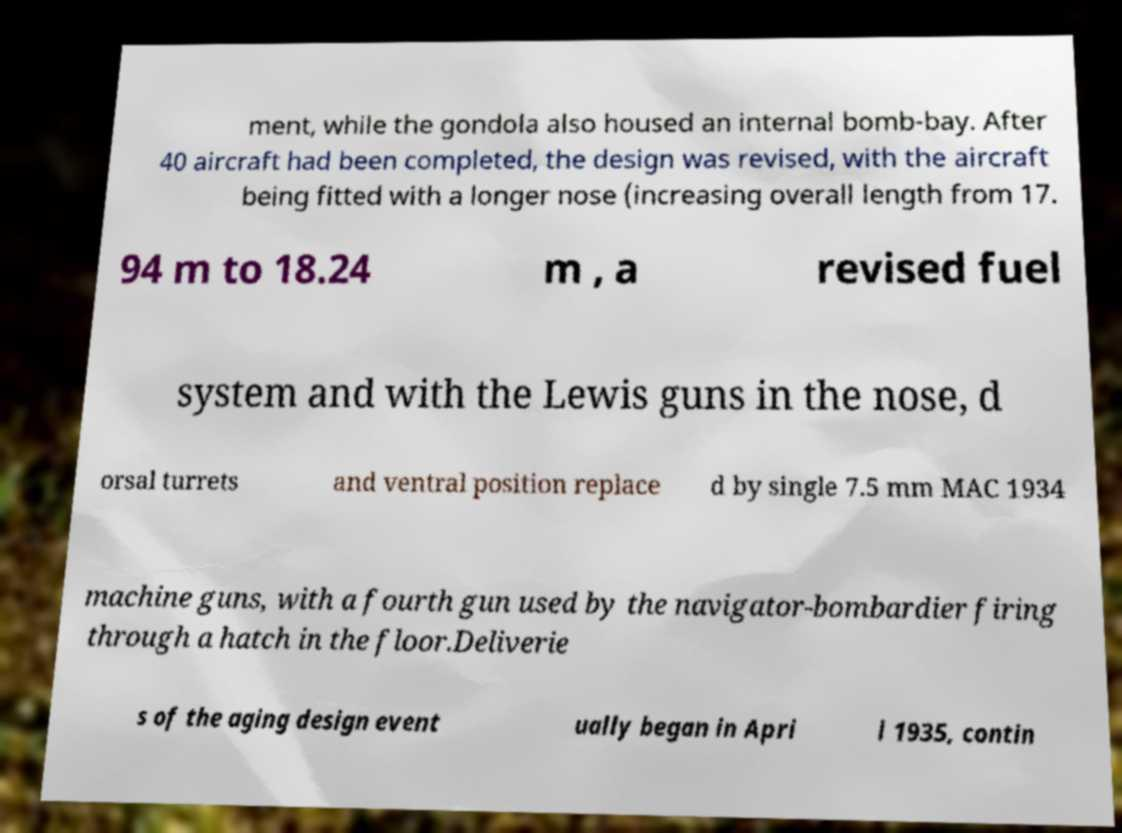Could you assist in decoding the text presented in this image and type it out clearly? ment, while the gondola also housed an internal bomb-bay. After 40 aircraft had been completed, the design was revised, with the aircraft being fitted with a longer nose (increasing overall length from 17. 94 m to 18.24 m , a revised fuel system and with the Lewis guns in the nose, d orsal turrets and ventral position replace d by single 7.5 mm MAC 1934 machine guns, with a fourth gun used by the navigator-bombardier firing through a hatch in the floor.Deliverie s of the aging design event ually began in Apri l 1935, contin 